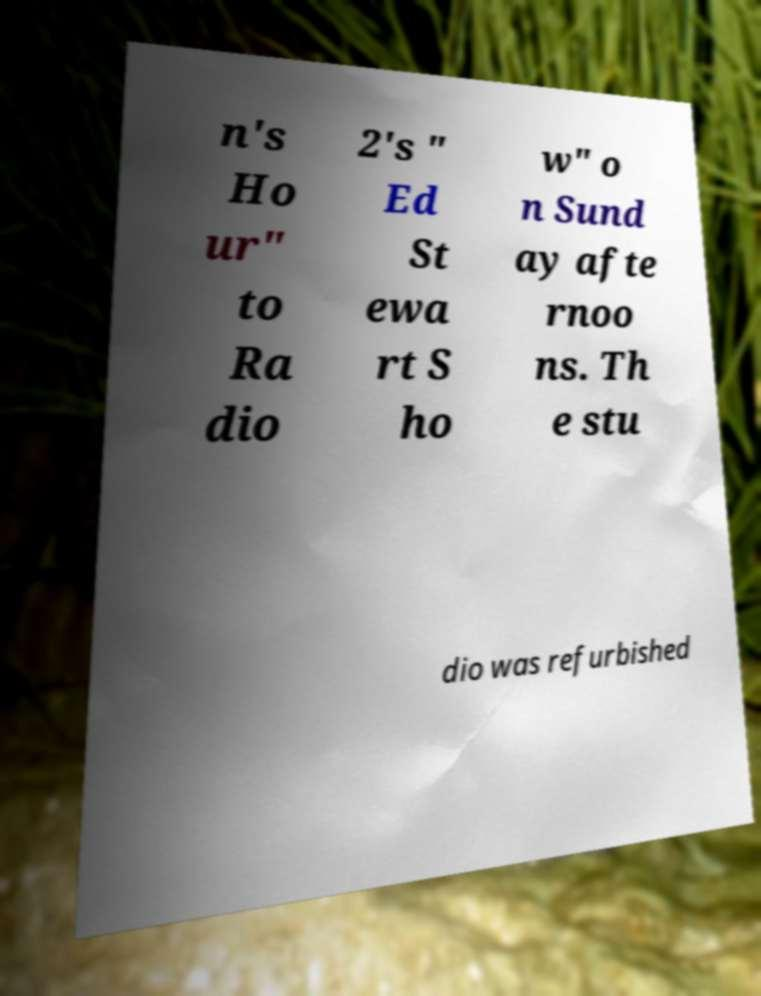Please identify and transcribe the text found in this image. n's Ho ur" to Ra dio 2's " Ed St ewa rt S ho w" o n Sund ay afte rnoo ns. Th e stu dio was refurbished 